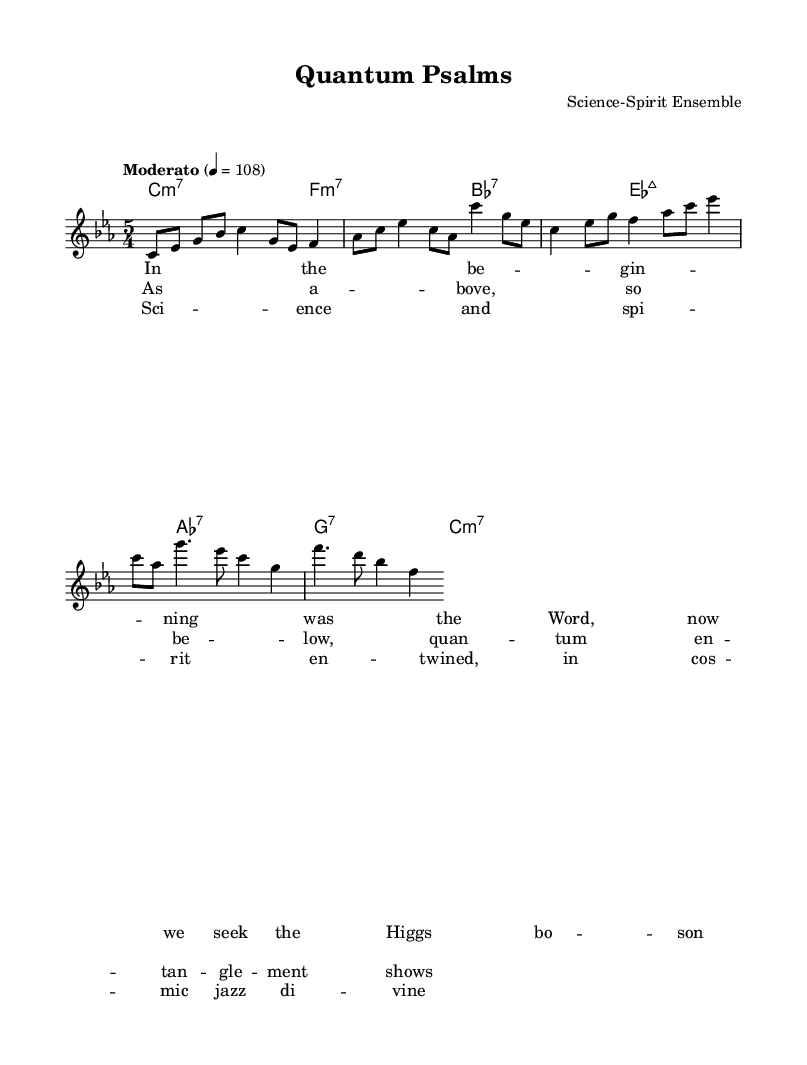What is the key signature of this music? The key signature is C minor, which has three flats: B flat, E flat, and A flat. This can be identified from the key indicated at the beginning of the score.
Answer: C minor What is the time signature of this piece? The time signature is 5/4, which indicates there are five beats in each measure and a quarter note gets one beat. This can be found at the beginning of the staff where the time signature is displayed.
Answer: 5/4 What is the tempo marking given for the piece? The tempo marking is "Moderato," which suggests a moderate pace for the performance. This is shown above the staff in the score where the tempo is indicated with a metronome mark of 108.
Answer: Moderato How many measures are in the chorus section? The chorus section consists of two measures. This can be determined by counting the measures from the score where the lyrics "Sci -- ence and spi -- rit en -- twined" are aligned with the melody notes.
Answer: 2 What type of harmony is primarily used in this piece? The primary harmony type used in this piece is seventh chords, indicated by the chord symbols shown beneath the staff. Each chord usually consists of a root, a third, a fifth, and a seventh, typical for jazz music.
Answer: seventh chords How do the melodies of the verses differ rhythmically from the chorus? The melodies of the verses use a mix of eighth and quarter notes to create a flowing feel, while the chorus employs a more syncopated rhythm with both dotted and regular notes, giving it a distinct contrast that is reflective of jazz styles. This contrast can be seen by comparing the rhythm patterns in the respective sections.
Answer: contrast 